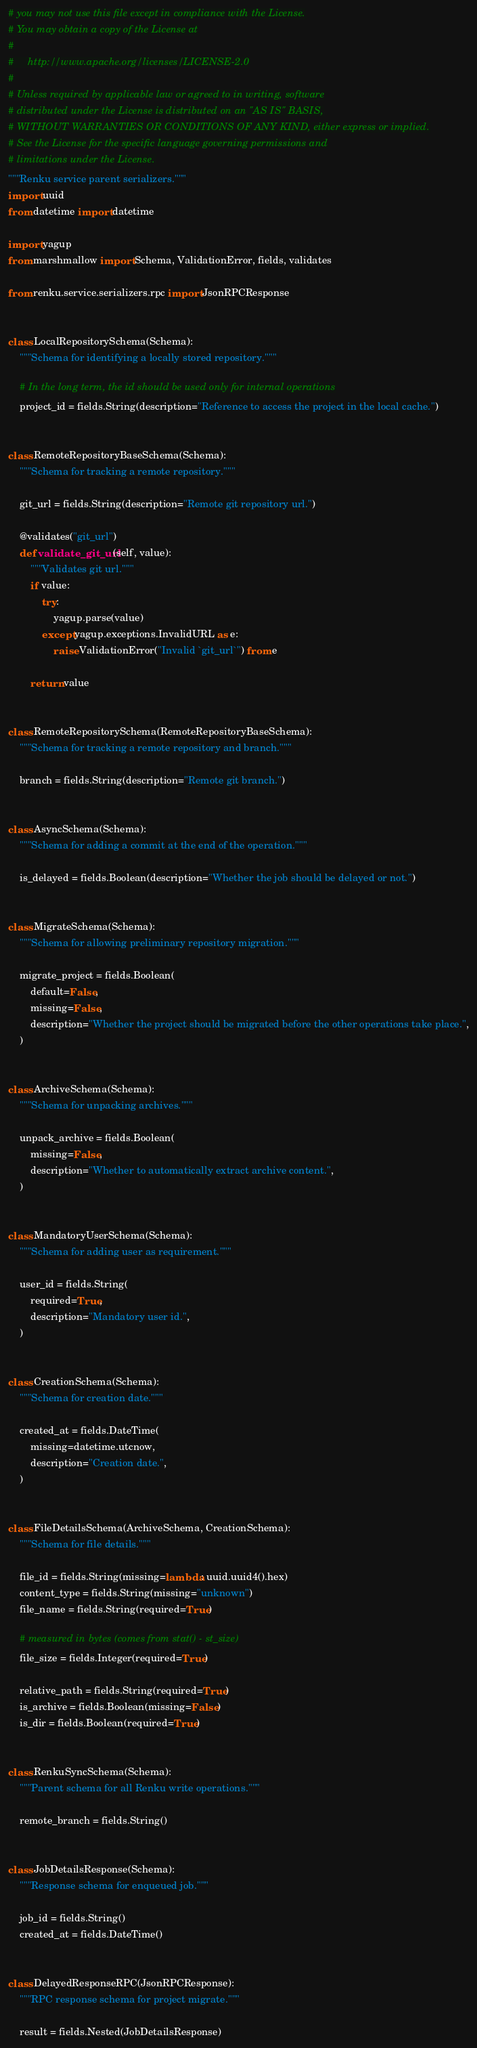Convert code to text. <code><loc_0><loc_0><loc_500><loc_500><_Python_># you may not use this file except in compliance with the License.
# You may obtain a copy of the License at
#
#     http://www.apache.org/licenses/LICENSE-2.0
#
# Unless required by applicable law or agreed to in writing, software
# distributed under the License is distributed on an "AS IS" BASIS,
# WITHOUT WARRANTIES OR CONDITIONS OF ANY KIND, either express or implied.
# See the License for the specific language governing permissions and
# limitations under the License.
"""Renku service parent serializers."""
import uuid
from datetime import datetime

import yagup
from marshmallow import Schema, ValidationError, fields, validates

from renku.service.serializers.rpc import JsonRPCResponse


class LocalRepositorySchema(Schema):
    """Schema for identifying a locally stored repository."""

    # In the long term, the id should be used only for internal operations
    project_id = fields.String(description="Reference to access the project in the local cache.")


class RemoteRepositoryBaseSchema(Schema):
    """Schema for tracking a remote repository."""

    git_url = fields.String(description="Remote git repository url.")

    @validates("git_url")
    def validate_git_url(self, value):
        """Validates git url."""
        if value:
            try:
                yagup.parse(value)
            except yagup.exceptions.InvalidURL as e:
                raise ValidationError("Invalid `git_url`") from e

        return value


class RemoteRepositorySchema(RemoteRepositoryBaseSchema):
    """Schema for tracking a remote repository and branch."""

    branch = fields.String(description="Remote git branch.")


class AsyncSchema(Schema):
    """Schema for adding a commit at the end of the operation."""

    is_delayed = fields.Boolean(description="Whether the job should be delayed or not.")


class MigrateSchema(Schema):
    """Schema for allowing preliminary repository migration."""

    migrate_project = fields.Boolean(
        default=False,
        missing=False,
        description="Whether the project should be migrated before the other operations take place.",
    )


class ArchiveSchema(Schema):
    """Schema for unpacking archives."""

    unpack_archive = fields.Boolean(
        missing=False,
        description="Whether to automatically extract archive content.",
    )


class MandatoryUserSchema(Schema):
    """Schema for adding user as requirement."""

    user_id = fields.String(
        required=True,
        description="Mandatory user id.",
    )


class CreationSchema(Schema):
    """Schema for creation date."""

    created_at = fields.DateTime(
        missing=datetime.utcnow,
        description="Creation date.",
    )


class FileDetailsSchema(ArchiveSchema, CreationSchema):
    """Schema for file details."""

    file_id = fields.String(missing=lambda: uuid.uuid4().hex)
    content_type = fields.String(missing="unknown")
    file_name = fields.String(required=True)

    # measured in bytes (comes from stat() - st_size)
    file_size = fields.Integer(required=True)

    relative_path = fields.String(required=True)
    is_archive = fields.Boolean(missing=False)
    is_dir = fields.Boolean(required=True)


class RenkuSyncSchema(Schema):
    """Parent schema for all Renku write operations."""

    remote_branch = fields.String()


class JobDetailsResponse(Schema):
    """Response schema for enqueued job."""

    job_id = fields.String()
    created_at = fields.DateTime()


class DelayedResponseRPC(JsonRPCResponse):
    """RPC response schema for project migrate."""

    result = fields.Nested(JobDetailsResponse)
</code> 